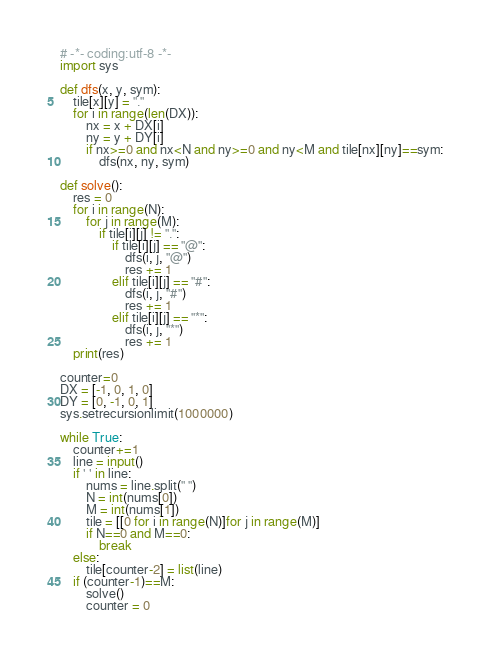Convert code to text. <code><loc_0><loc_0><loc_500><loc_500><_Python_># -*- coding:utf-8 -*-
import sys

def dfs(x, y, sym):
	tile[x][y] = "."
	for i in range(len(DX)):
		nx = x + DX[i]
		ny = y + DY[i]
		if nx>=0 and nx<N and ny>=0 and ny<M and tile[nx][ny]==sym:
			dfs(nx, ny, sym)

def solve():
	res = 0
	for i in range(N):
		for j in range(M):
			if tile[i][j] != ".":
				if tile[i][j] == "@":
					dfs(i, j, "@")
					res += 1
				elif tile[i][j] == "#":
					dfs(i, j, "#")
					res += 1
				elif tile[i][j] == "*":
					dfs(i, j, "*")
					res += 1
	print(res)

counter=0
DX = [-1, 0, 1, 0]
DY = [0, -1, 0, 1]
sys.setrecursionlimit(1000000)

while True:
	counter+=1
	line = input()
	if ' ' in line:
		nums = line.split(" ")
		N = int(nums[0])
		M = int(nums[1])
		tile = [[0 for i in range(N)]for j in range(M)]
		if N==0 and M==0:
			break
	else:
		tile[counter-2] = list(line)
	if (counter-1)==M:
		solve()
		counter = 0</code> 